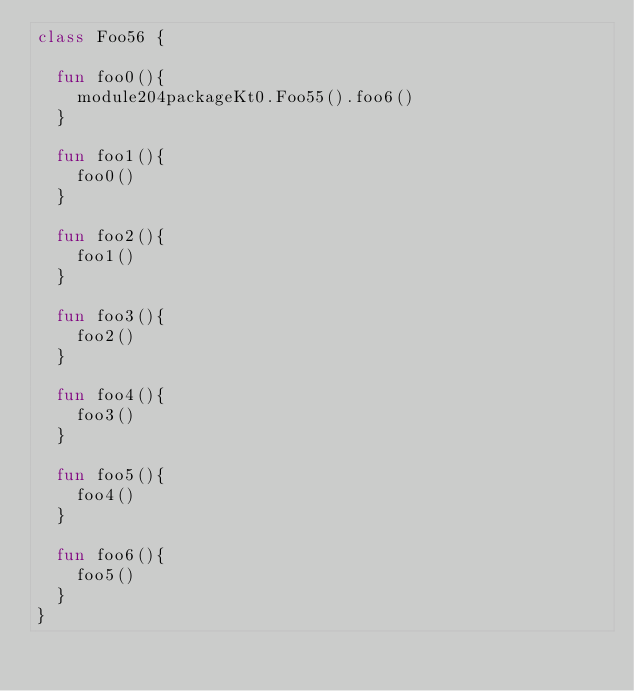Convert code to text. <code><loc_0><loc_0><loc_500><loc_500><_Kotlin_>class Foo56 {

  fun foo0(){
    module204packageKt0.Foo55().foo6()
  }

  fun foo1(){
    foo0()
  }

  fun foo2(){
    foo1()
  }

  fun foo3(){
    foo2()
  }

  fun foo4(){
    foo3()
  }

  fun foo5(){
    foo4()
  }

  fun foo6(){
    foo5()
  }
}</code> 